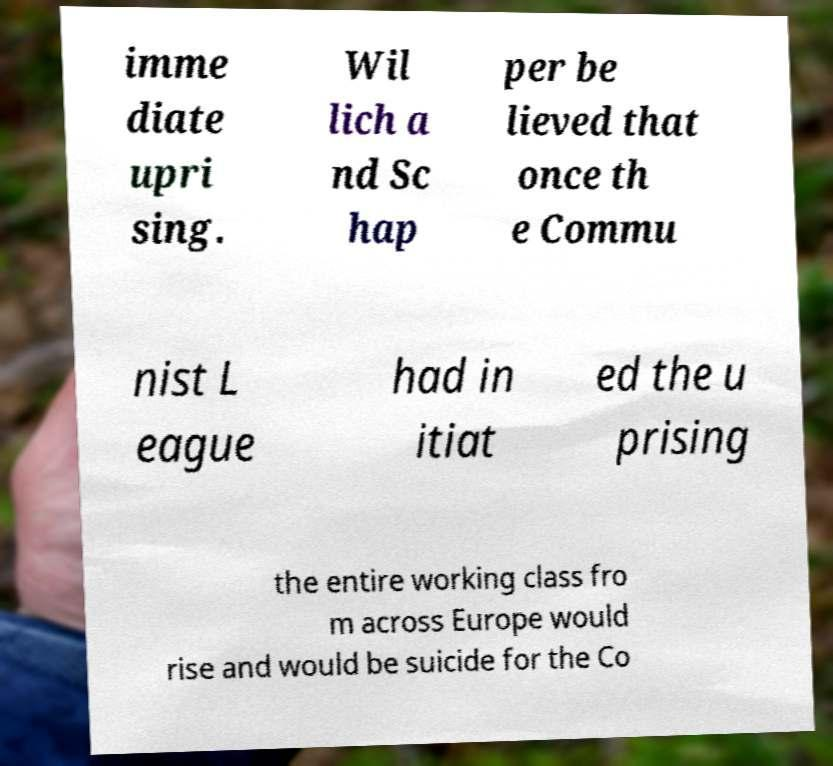Please read and relay the text visible in this image. What does it say? imme diate upri sing. Wil lich a nd Sc hap per be lieved that once th e Commu nist L eague had in itiat ed the u prising the entire working class fro m across Europe would rise and would be suicide for the Co 